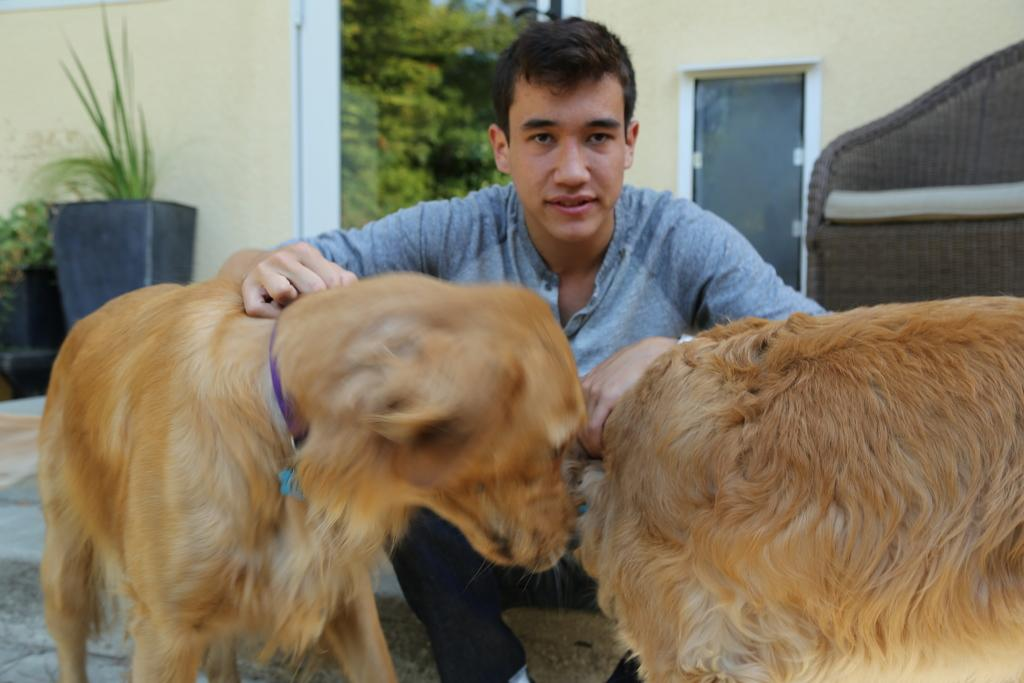Who is present in the image? There is a man in the image. What is the man doing with his hands? The man has both hands on two dogs. What can be seen in the background of the image? There is a wall, two plants, and trees in the background of the image. Where is the faucet located in the image? There is no faucet present in the image. What type of tin is being used by the man in the image? There is no tin present in the image; the man is holding two dogs. 